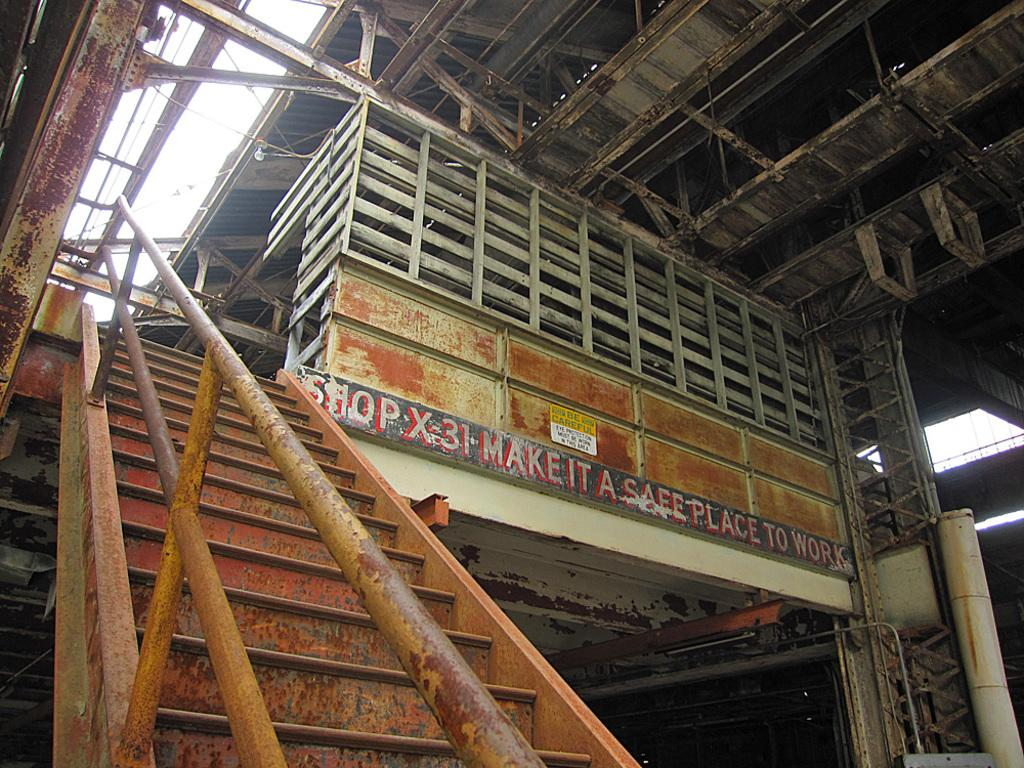What type of steps are present in the image? There are iron steps in the image. What feature do the iron steps have? The iron steps have pipe railing. What structure is visible above the steps? There is an iron shed visible above the steps. What part of the natural environment can be seen in the image? The sky is visible in the image. What type of bead is used to decorate the iron shed in the image? There is no bead present or used to decorate the iron shed in the image. 